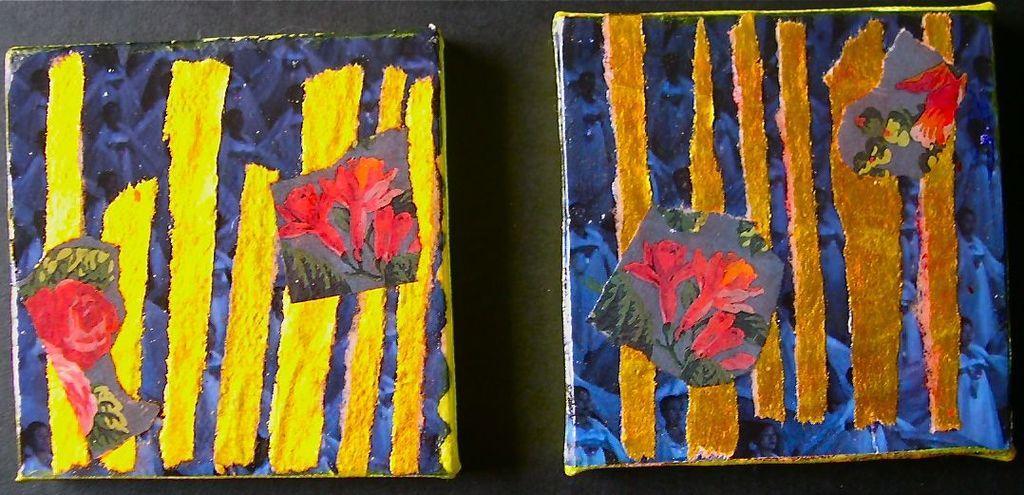Please provide a concise description of this image. In this image I can see there are two posters painted with colors and they are placed on a black surface. 